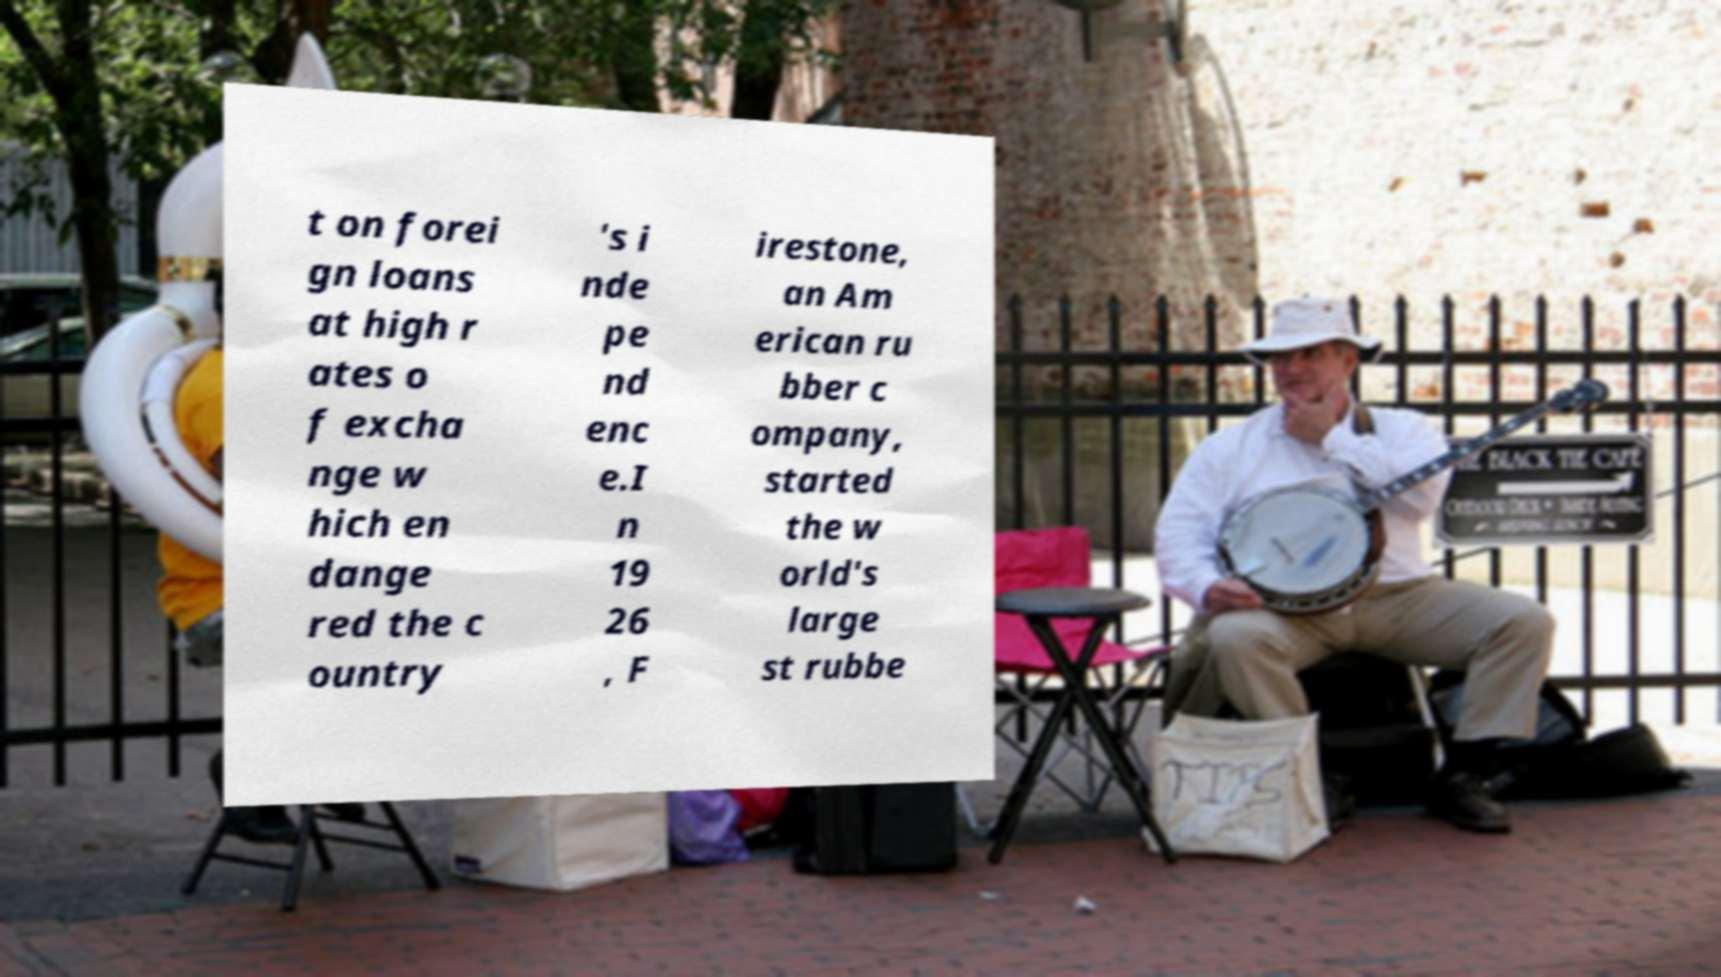What messages or text are displayed in this image? I need them in a readable, typed format. t on forei gn loans at high r ates o f excha nge w hich en dange red the c ountry 's i nde pe nd enc e.I n 19 26 , F irestone, an Am erican ru bber c ompany, started the w orld's large st rubbe 